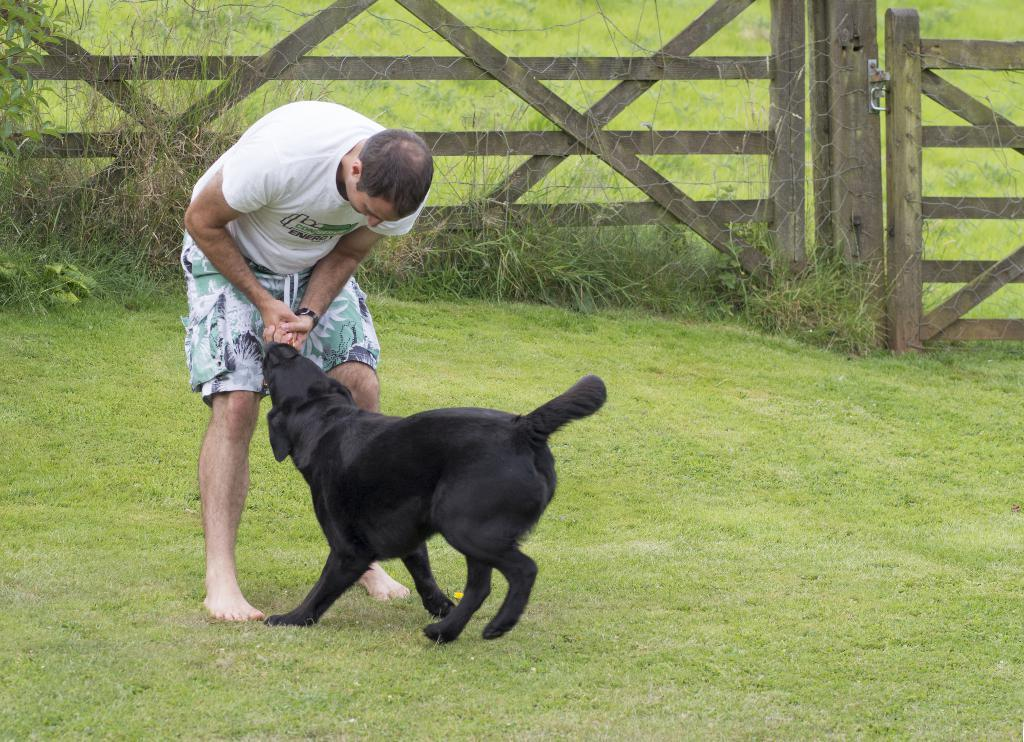Who is present in the image? There is a man in the image. What is the man doing in the image? The man is playing with a dog. Can you describe the dog in the image? The dog is black in color. Where does the scene take place? The scene takes place in a garden. What can be seen in the background of the image? There is a wooden railing and plants in the background of the image. What force is being used by the man to control the sister in the image? There is no sister present in the image, and the man is playing with a dog, not controlling a sister. 